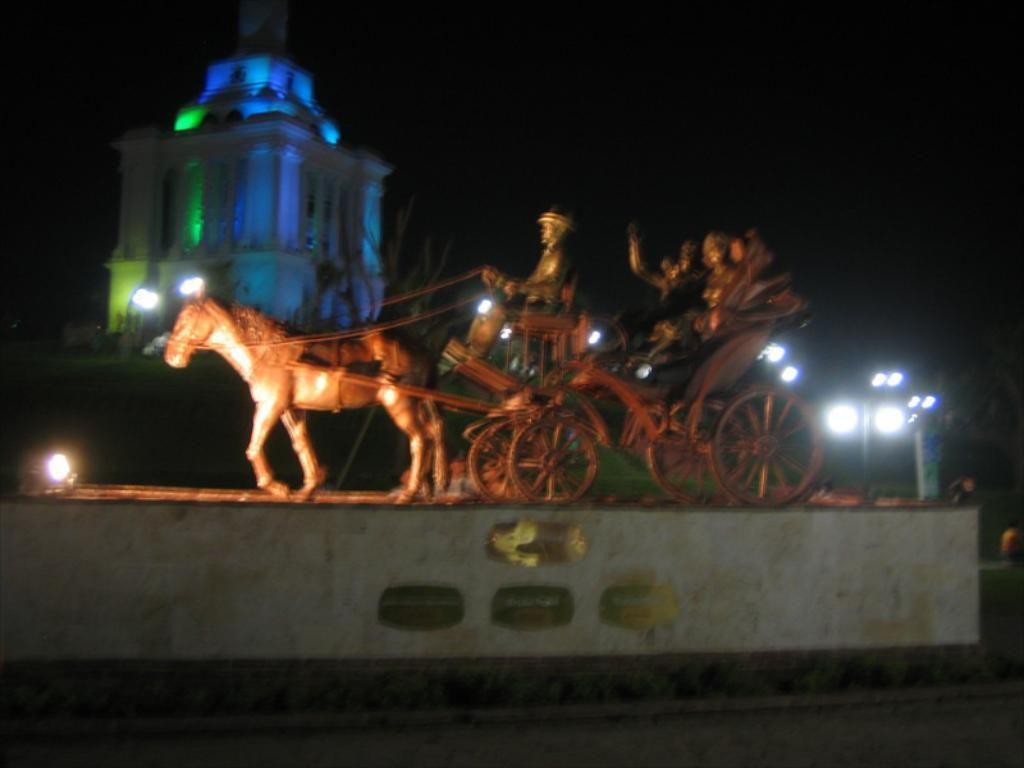What is the main subject in the middle of the image? There is a horse cart in the middle of the image. What structure can be seen at the top left side of the image? There is a building at the top left side of the image. What can be seen on the right side of the image? There are some lights on the right side of the image. What grade is the horse cart in the image? The horse cart is not in a grade, as it is an object and not a student or a participant in a grading system. 